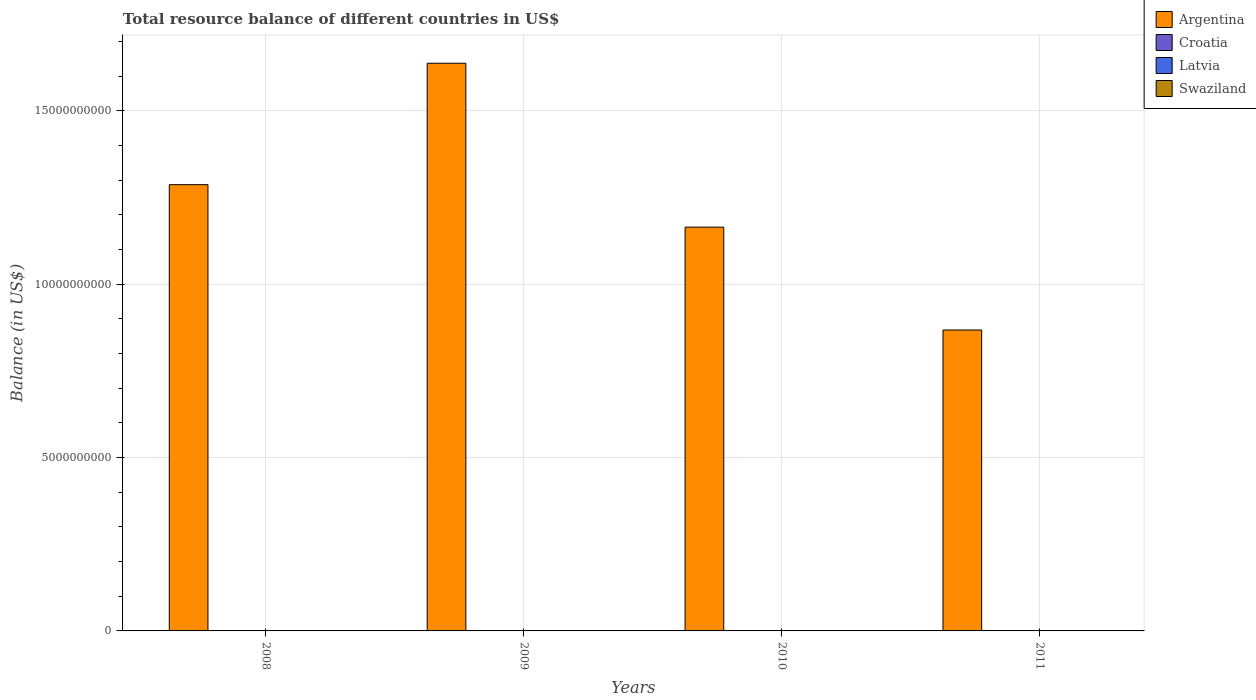How many bars are there on the 1st tick from the left?
Your answer should be very brief. 1. How many bars are there on the 3rd tick from the right?
Ensure brevity in your answer.  1. What is the label of the 2nd group of bars from the left?
Your answer should be compact. 2009. In how many cases, is the number of bars for a given year not equal to the number of legend labels?
Give a very brief answer. 4. What is the total resource balance in Swaziland in 2009?
Your answer should be compact. 0. Across all years, what is the maximum total resource balance in Argentina?
Keep it short and to the point. 1.64e+1. Across all years, what is the minimum total resource balance in Croatia?
Offer a very short reply. 0. In which year was the total resource balance in Argentina maximum?
Keep it short and to the point. 2009. What is the difference between the total resource balance in Argentina in 2008 and that in 2011?
Make the answer very short. 4.19e+09. What is the difference between the total resource balance in Croatia in 2011 and the total resource balance in Argentina in 2010?
Give a very brief answer. -1.16e+1. What is the average total resource balance in Argentina per year?
Make the answer very short. 1.24e+1. In how many years, is the total resource balance in Latvia greater than 9000000000 US$?
Your answer should be very brief. 0. What is the difference between the highest and the second highest total resource balance in Argentina?
Your answer should be compact. 3.50e+09. In how many years, is the total resource balance in Latvia greater than the average total resource balance in Latvia taken over all years?
Ensure brevity in your answer.  0. Is it the case that in every year, the sum of the total resource balance in Swaziland and total resource balance in Croatia is greater than the sum of total resource balance in Latvia and total resource balance in Argentina?
Provide a succinct answer. No. Is it the case that in every year, the sum of the total resource balance in Argentina and total resource balance in Croatia is greater than the total resource balance in Swaziland?
Your answer should be very brief. Yes. How many bars are there?
Offer a very short reply. 4. How many years are there in the graph?
Ensure brevity in your answer.  4. Are the values on the major ticks of Y-axis written in scientific E-notation?
Offer a terse response. No. Does the graph contain any zero values?
Give a very brief answer. Yes. How are the legend labels stacked?
Offer a very short reply. Vertical. What is the title of the graph?
Ensure brevity in your answer.  Total resource balance of different countries in US$. Does "Costa Rica" appear as one of the legend labels in the graph?
Your answer should be compact. No. What is the label or title of the Y-axis?
Ensure brevity in your answer.  Balance (in US$). What is the Balance (in US$) in Argentina in 2008?
Provide a short and direct response. 1.29e+1. What is the Balance (in US$) in Croatia in 2008?
Give a very brief answer. 0. What is the Balance (in US$) of Latvia in 2008?
Make the answer very short. 0. What is the Balance (in US$) in Argentina in 2009?
Keep it short and to the point. 1.64e+1. What is the Balance (in US$) in Croatia in 2009?
Ensure brevity in your answer.  0. What is the Balance (in US$) in Swaziland in 2009?
Ensure brevity in your answer.  0. What is the Balance (in US$) in Argentina in 2010?
Provide a succinct answer. 1.16e+1. What is the Balance (in US$) of Croatia in 2010?
Provide a succinct answer. 0. What is the Balance (in US$) in Swaziland in 2010?
Offer a terse response. 0. What is the Balance (in US$) in Argentina in 2011?
Provide a succinct answer. 8.68e+09. What is the Balance (in US$) in Latvia in 2011?
Provide a succinct answer. 0. Across all years, what is the maximum Balance (in US$) in Argentina?
Your answer should be very brief. 1.64e+1. Across all years, what is the minimum Balance (in US$) of Argentina?
Offer a terse response. 8.68e+09. What is the total Balance (in US$) in Argentina in the graph?
Your response must be concise. 4.96e+1. What is the total Balance (in US$) of Latvia in the graph?
Make the answer very short. 0. What is the total Balance (in US$) in Swaziland in the graph?
Your answer should be very brief. 0. What is the difference between the Balance (in US$) of Argentina in 2008 and that in 2009?
Give a very brief answer. -3.50e+09. What is the difference between the Balance (in US$) in Argentina in 2008 and that in 2010?
Make the answer very short. 1.22e+09. What is the difference between the Balance (in US$) in Argentina in 2008 and that in 2011?
Your answer should be compact. 4.19e+09. What is the difference between the Balance (in US$) in Argentina in 2009 and that in 2010?
Give a very brief answer. 4.73e+09. What is the difference between the Balance (in US$) of Argentina in 2009 and that in 2011?
Your answer should be compact. 7.69e+09. What is the difference between the Balance (in US$) in Argentina in 2010 and that in 2011?
Keep it short and to the point. 2.97e+09. What is the average Balance (in US$) in Argentina per year?
Provide a succinct answer. 1.24e+1. What is the average Balance (in US$) of Croatia per year?
Offer a very short reply. 0. What is the average Balance (in US$) in Latvia per year?
Offer a terse response. 0. What is the ratio of the Balance (in US$) in Argentina in 2008 to that in 2009?
Offer a very short reply. 0.79. What is the ratio of the Balance (in US$) in Argentina in 2008 to that in 2010?
Provide a short and direct response. 1.11. What is the ratio of the Balance (in US$) in Argentina in 2008 to that in 2011?
Provide a short and direct response. 1.48. What is the ratio of the Balance (in US$) in Argentina in 2009 to that in 2010?
Provide a succinct answer. 1.41. What is the ratio of the Balance (in US$) in Argentina in 2009 to that in 2011?
Give a very brief answer. 1.89. What is the ratio of the Balance (in US$) of Argentina in 2010 to that in 2011?
Your answer should be compact. 1.34. What is the difference between the highest and the second highest Balance (in US$) in Argentina?
Your answer should be very brief. 3.50e+09. What is the difference between the highest and the lowest Balance (in US$) in Argentina?
Ensure brevity in your answer.  7.69e+09. 